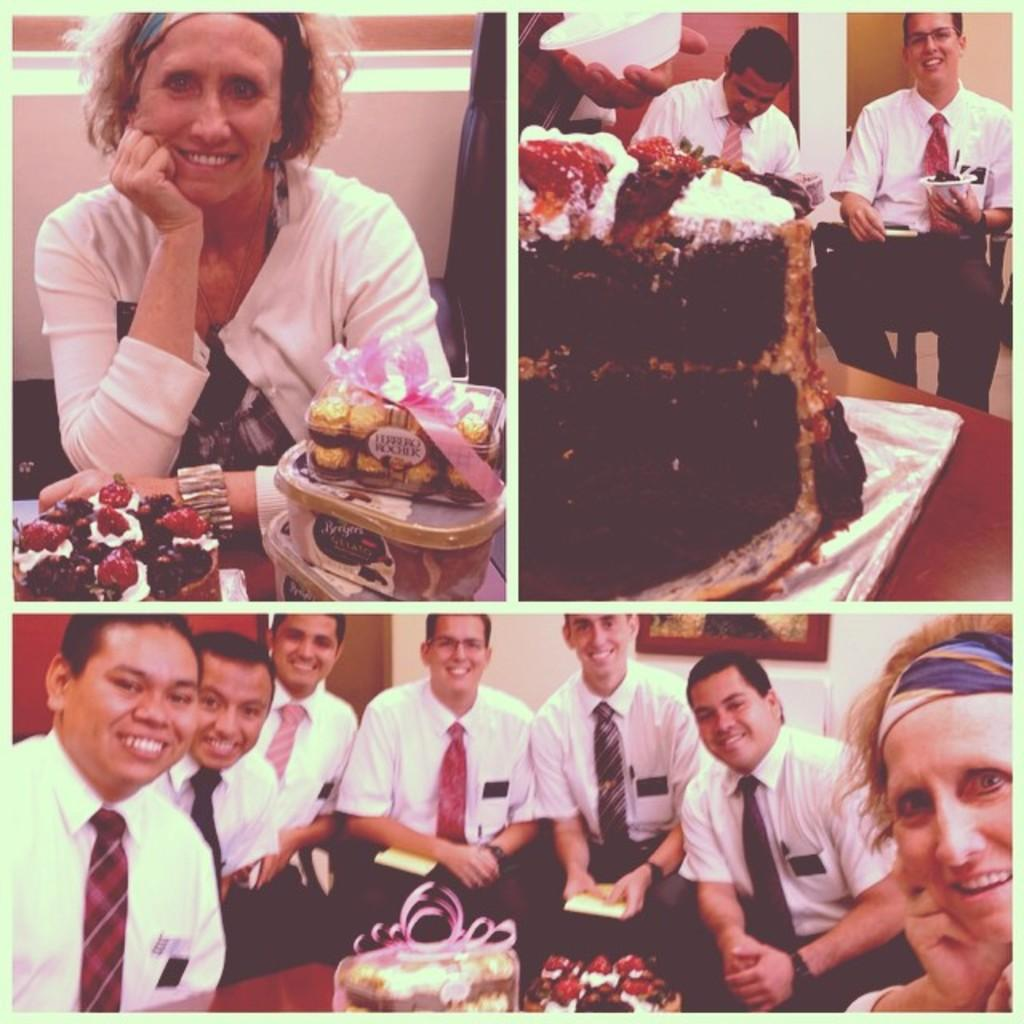What is the main subject of the image? The image contains a collage of three pictures. What can be seen in each of the pictures? There are people sitting in the pictures. Where are the people sitting in the pictures? The people are sitting in front of a table. What is on the table in the pictures? There are cakes on the table. What type of car is visible in the image? There is no car present in the image; it features a collage of three pictures with people sitting in front of a table with cakes. 